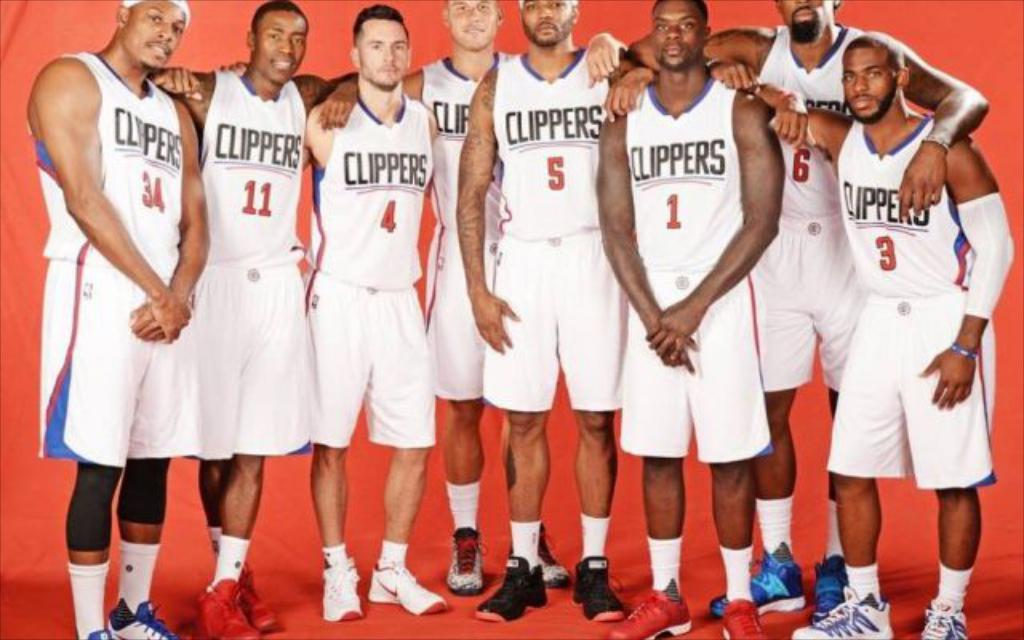How many people are in the image? There are persons standing in the image. What are the people wearing in the image? The persons are wearing white shirts. Are there any details on the shirts? Yes, there is text and numbers written on the shirts. What can be seen in the background of the image? There is a red curtain in the background of the image. What type of wood can be seen in the alley behind the persons in the image? There is no alley or wood present in the image; it features persons standing in front of a red curtain. What is the average income of the persons in the image? There is no information about the persons' income in the image. 